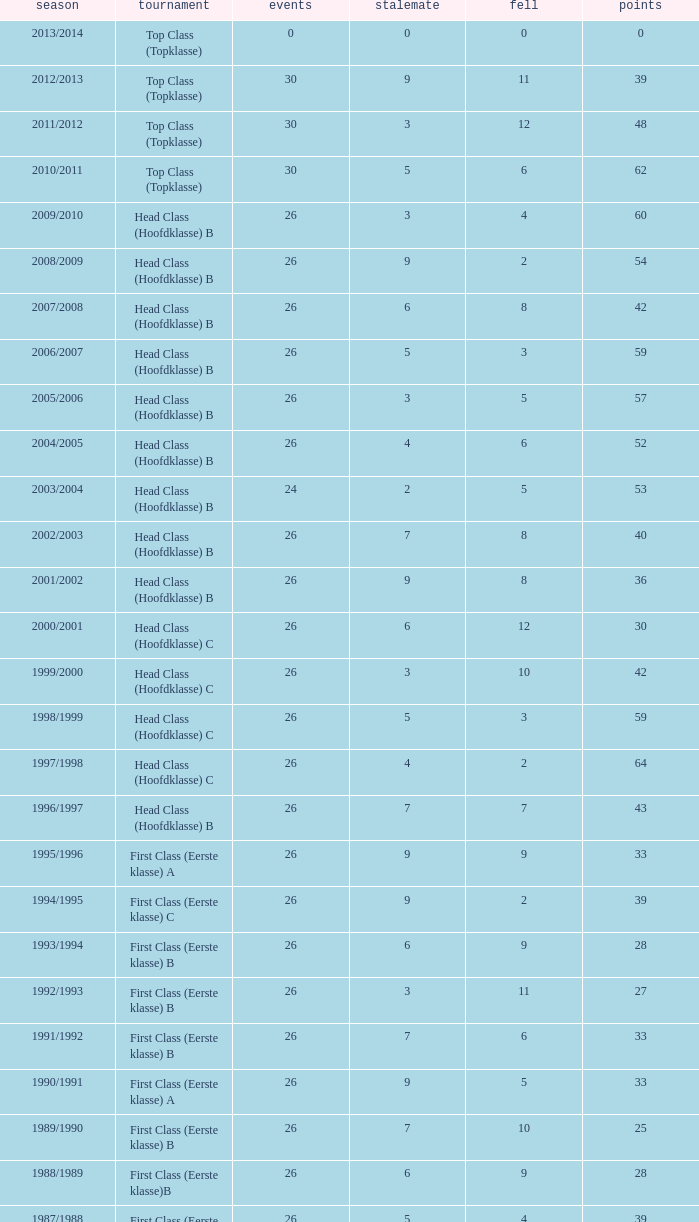What competition has a score greater than 30, a draw less than 5, and a loss larger than 10? Top Class (Topklasse). 